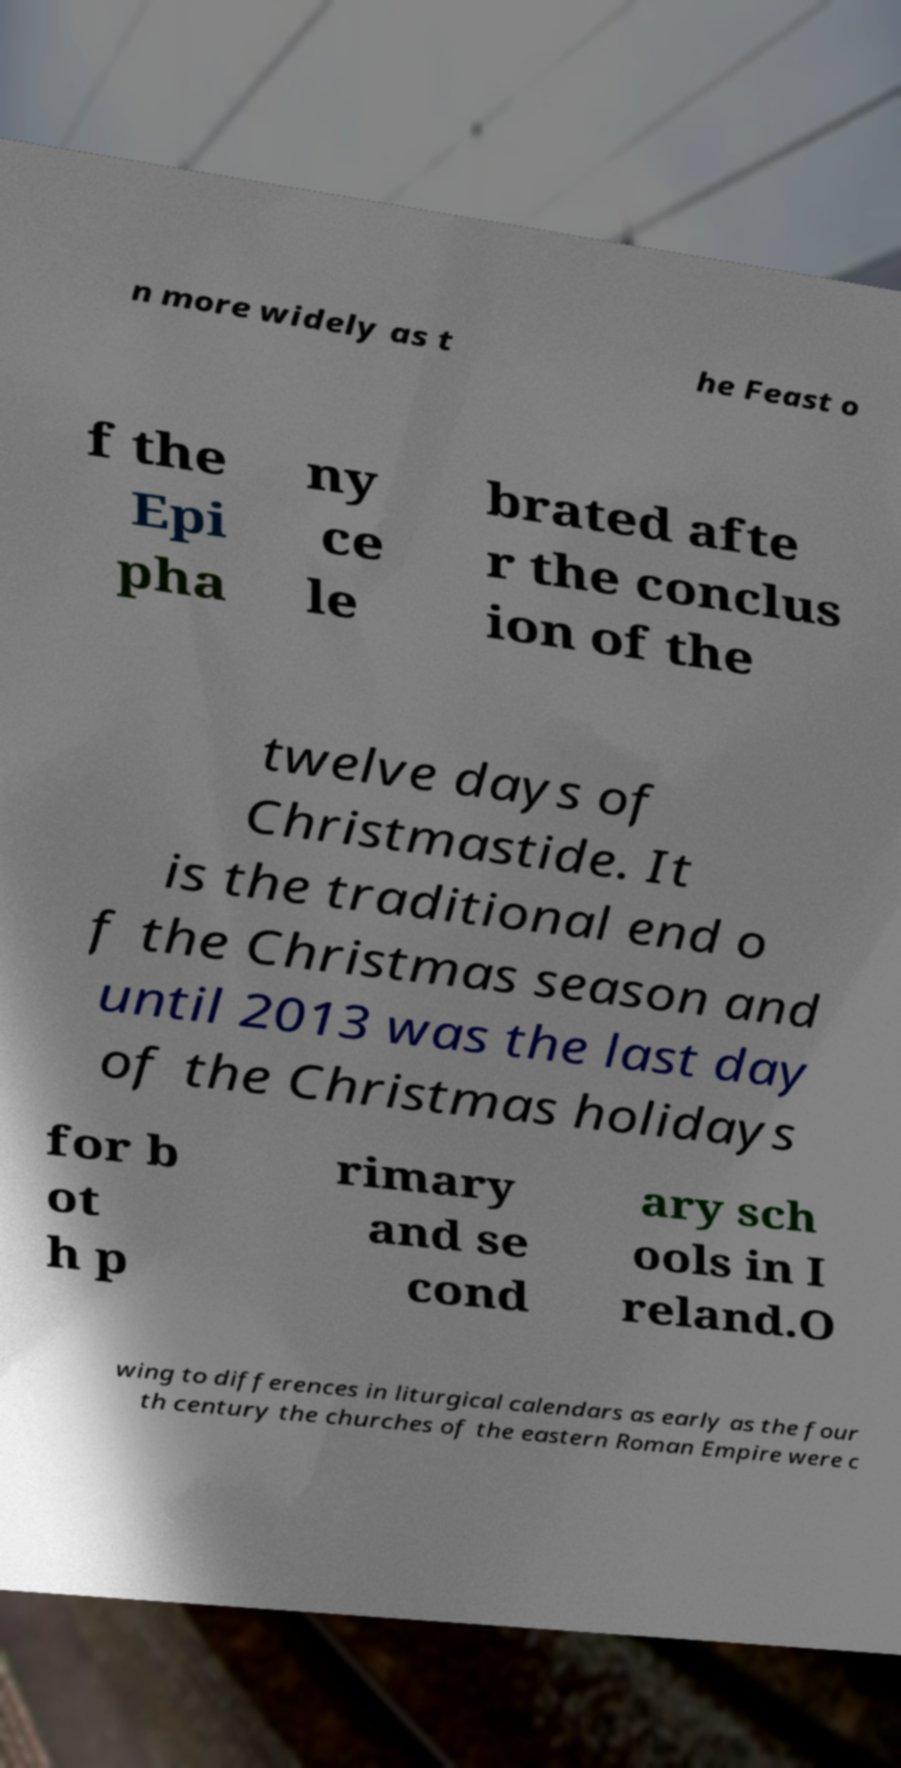Please read and relay the text visible in this image. What does it say? n more widely as t he Feast o f the Epi pha ny ce le brated afte r the conclus ion of the twelve days of Christmastide. It is the traditional end o f the Christmas season and until 2013 was the last day of the Christmas holidays for b ot h p rimary and se cond ary sch ools in I reland.O wing to differences in liturgical calendars as early as the four th century the churches of the eastern Roman Empire were c 